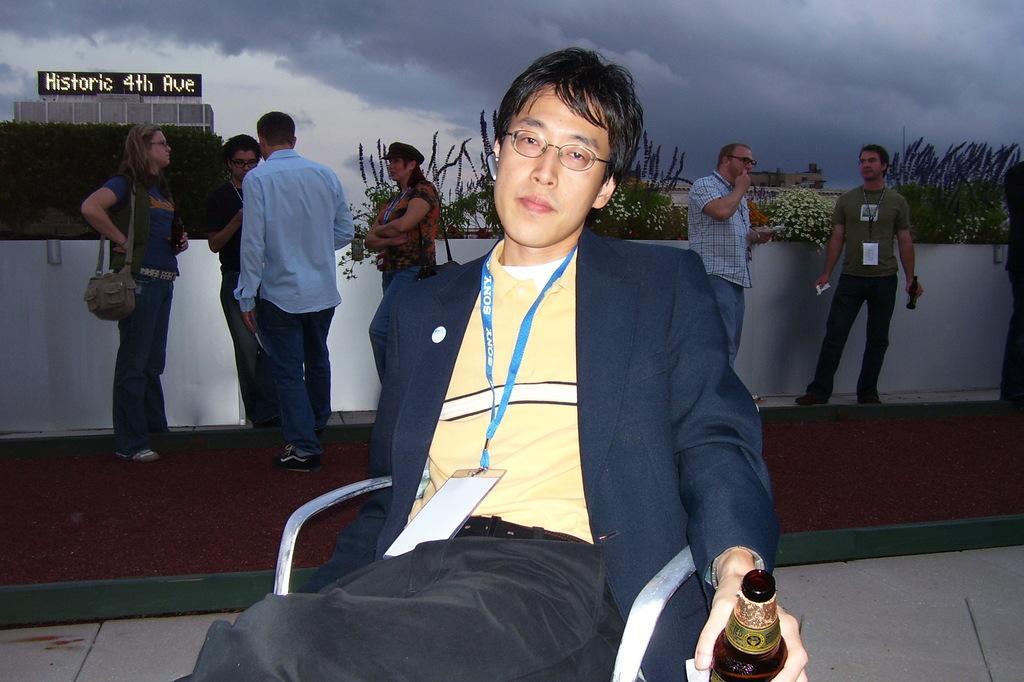Please provide a concise description of this image. This picture is of outside. In the center there is a man wearing blue color blazer, holding a bottle and sitting on the chair. On the right there is a man wearing green color t-shirt holding a bottle and standing and a man wearing white color shirt and standing. On the left there are group of people standing. In the background we can see the planets, sky full of clouds and the buildings. 